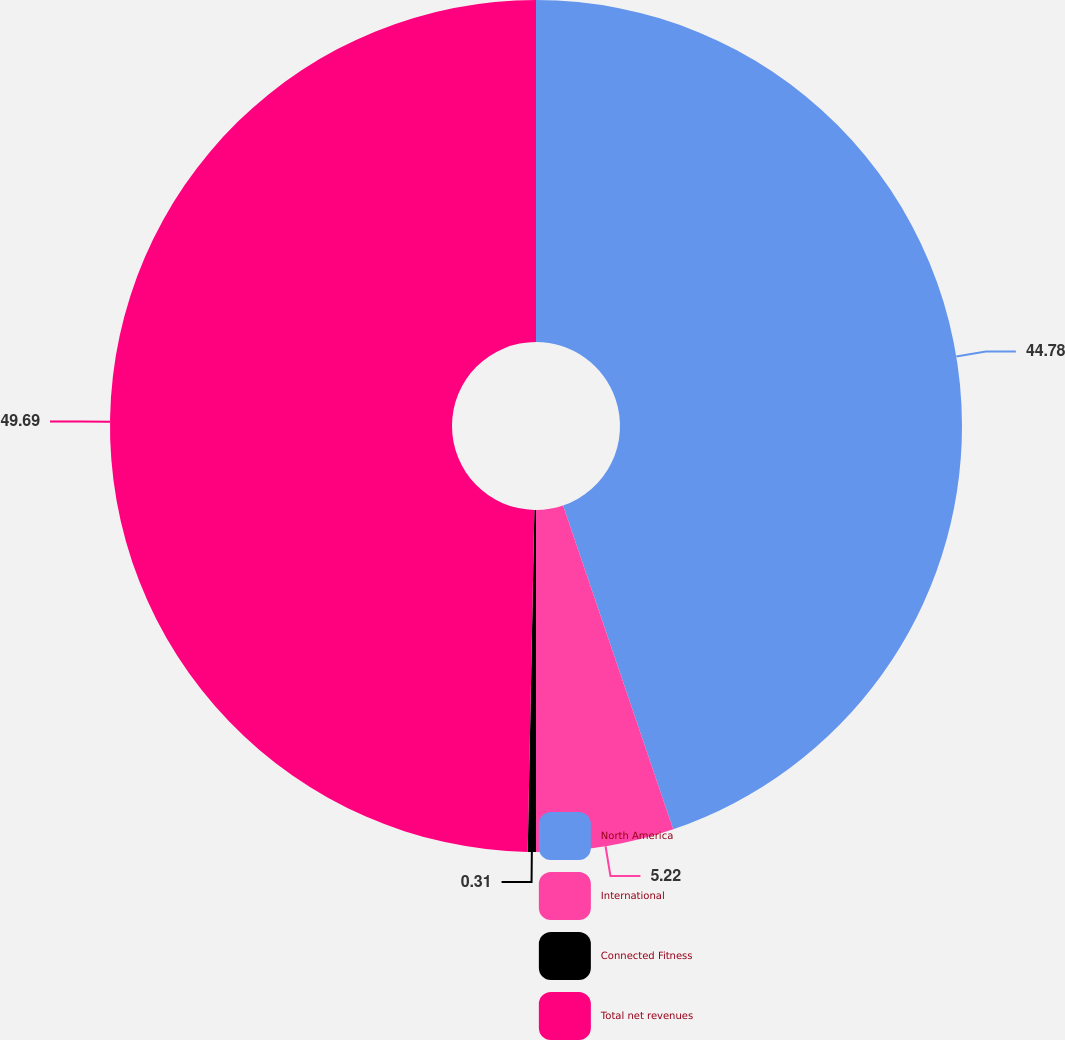<chart> <loc_0><loc_0><loc_500><loc_500><pie_chart><fcel>North America<fcel>International<fcel>Connected Fitness<fcel>Total net revenues<nl><fcel>44.78%<fcel>5.22%<fcel>0.31%<fcel>49.69%<nl></chart> 